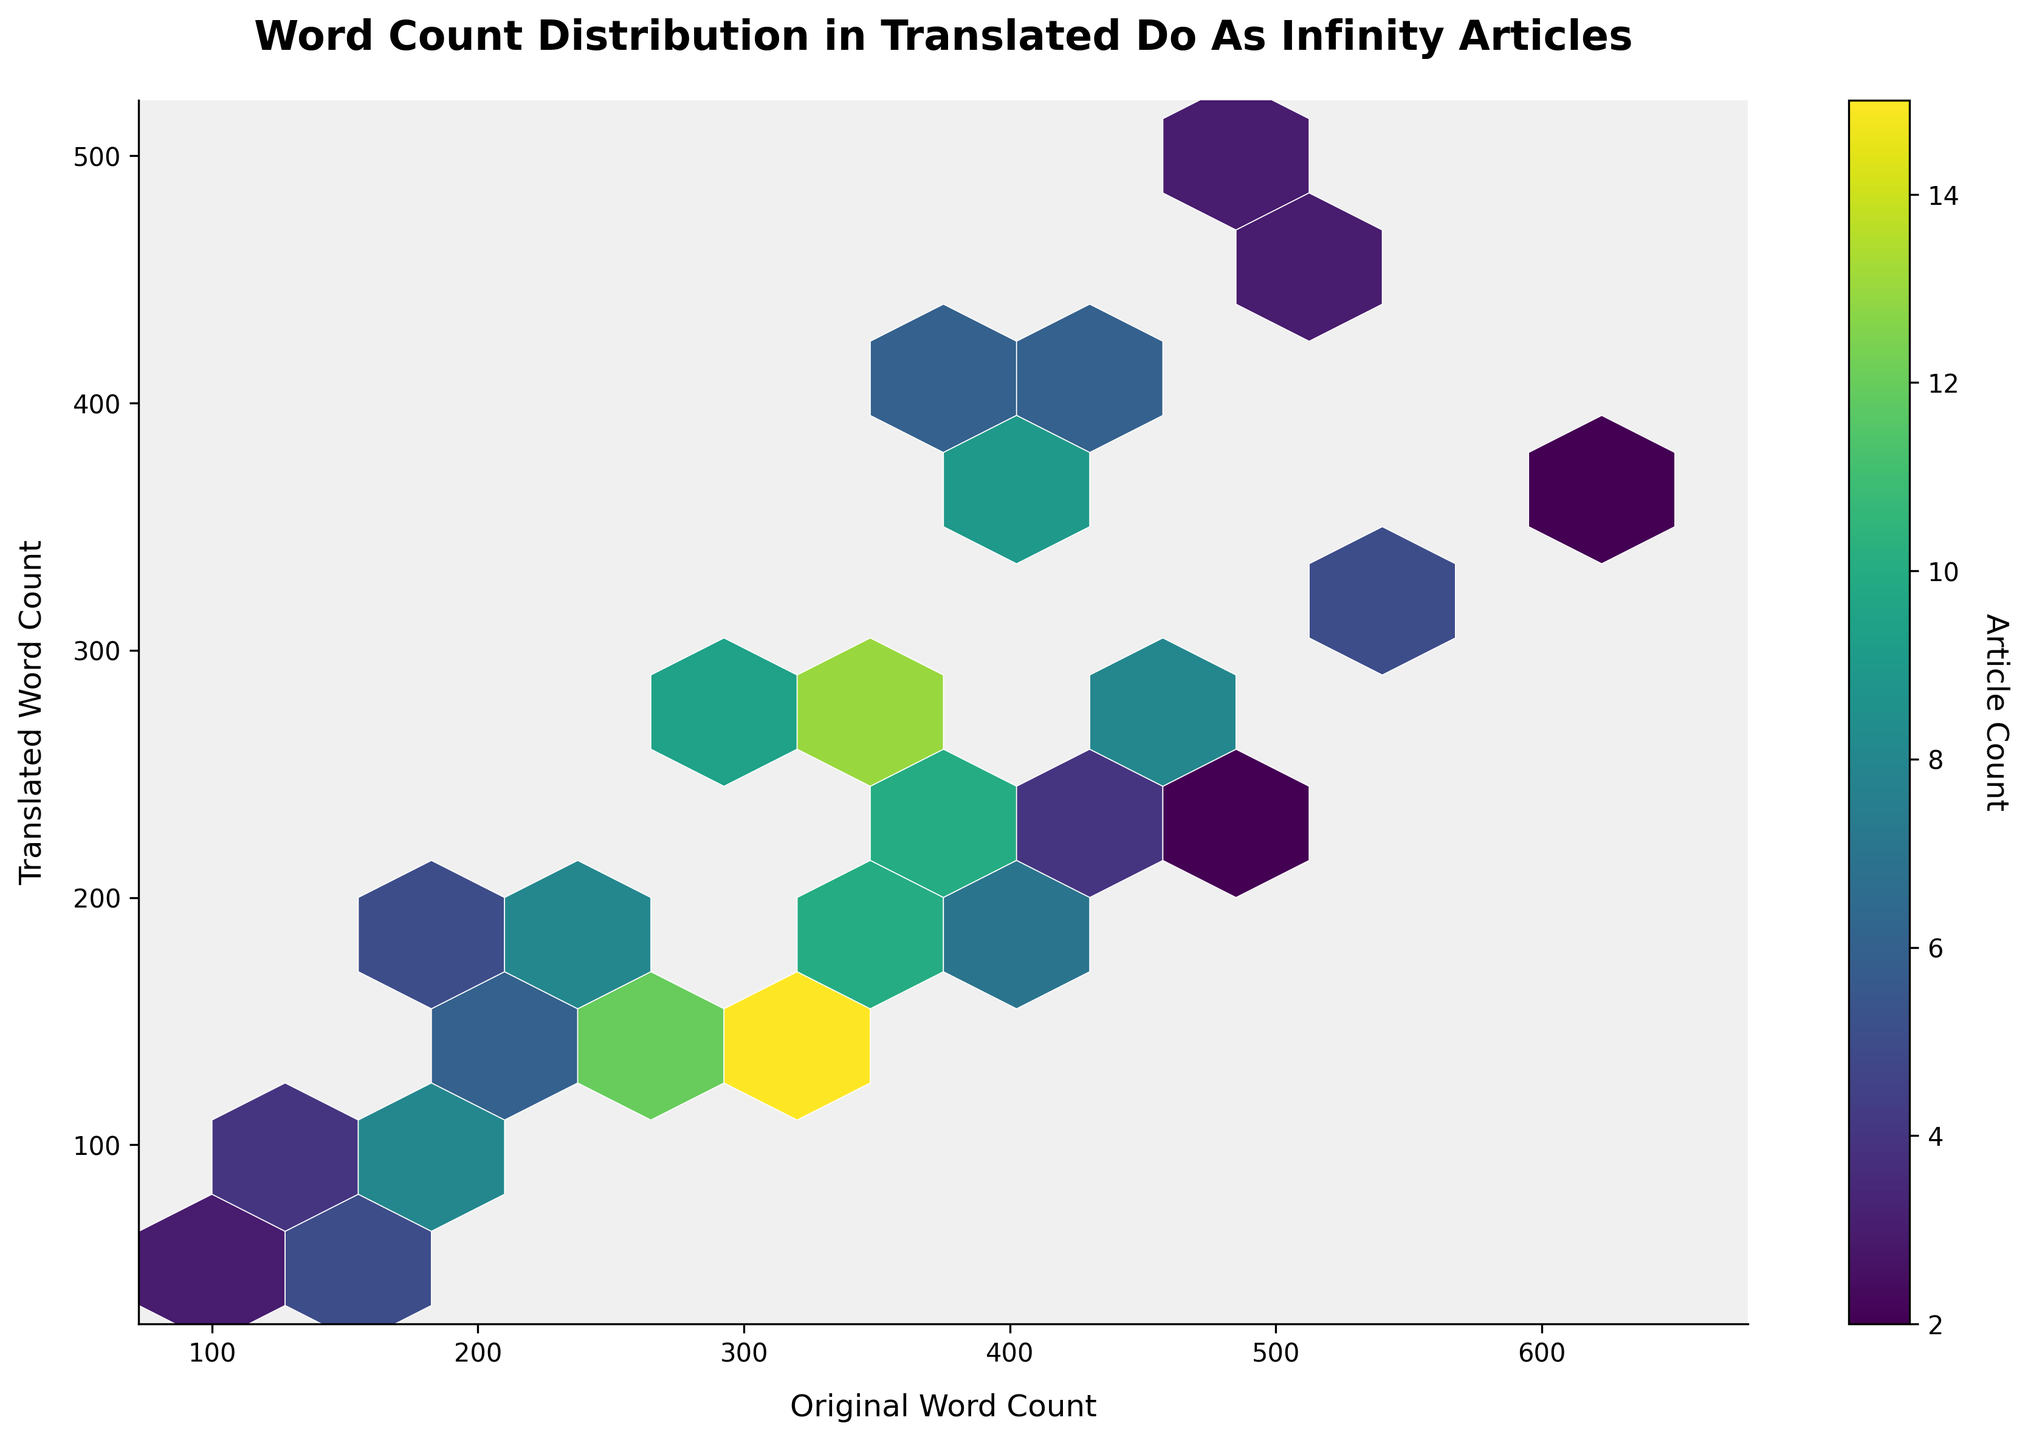What is the title of the hexbin plot? The title of the plot is usually located at the top center, and it describes what the plot is about. In this figure, the title reads "Word Count Distribution in Translated Do As Infinity Articles."
Answer: Word Count Distribution in Translated Do As Infinity Articles What do the axes labels indicate? The axes labels are found along the x and y axes and provide information about what each axis represents. In this plot, the x-axis is labeled "Original Word Count," and the y-axis is labeled "Translated Word Count."
Answer: Original Word Count and Translated Word Count Which color represents the highest article count? The color representing the highest article count can be observed by looking at the colorbar. In the color map used (viridis), darker colors correspond to higher values. The darkest color represents the highest article count.
Answer: Darkest color Where is the highest concentration of data points in the plot? To identify the highest concentration of data points, observe the hexagons with the darkest color. These regions appear where the original and translated word counts are closer, specifically around mid-ranges like (250, 125) and (350, 225).
Answer: Around (250, 125) and (350, 225) How does the distribution of original word count relate to the translated word count? To determine the relationship, look at the overall scattering of hexagons. They appear to be diagonally clustered, indicating a proportional relationship where higher original word counts relate to higher translated word counts.
Answer: Proportional relationship What’s the article count for the hexagon at (450, 225)? The hexagon located at (450, 225) can be identified, and the count can be read from the colorbar and the plot. For the given data, (450, 225) has an article count of 4.
Answer: 4 How does the article count compare between (300, 150) and (300, 250)? Comparing the two hexagons, the data shows that (300, 150) has an article count of 15 while (300, 250) has an article count of 11.
Answer: (300, 150) has a higher article count than (300, 250) Which section of the plot shows lower article counts, the top-left or the bottom-right? Observing the color intensity: lighter colors represent lower counts. The top-left section has fewer and lighter hexagons, whereas the bottom-right section also shows sparse and lighter hexagons, but generally, the bottom-right has slightly higher counts.
Answer: Top-left Which original word count range has the highest density of translated word counts? By observing the horizontal spread of the densest region, the original word count ranges from approximately 250 to 350. This range shows the most hexagons and darkest colors, indicating higher density.
Answer: 250 to 350 What does the white grid indicate in the plot? The white lines around the hexagons delineate the bins in the hexbin plot. They help to separate individual hexagons clearly but do not indicate any data value themselves.
Answer: Bins boundaries 